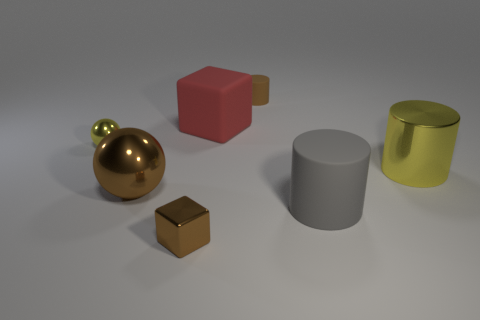Add 2 small brown balls. How many objects exist? 9 Subtract all cylinders. How many objects are left? 4 Add 7 brown rubber things. How many brown rubber things exist? 8 Subtract 0 gray cubes. How many objects are left? 7 Subtract all large metallic cubes. Subtract all metal objects. How many objects are left? 3 Add 7 gray objects. How many gray objects are left? 8 